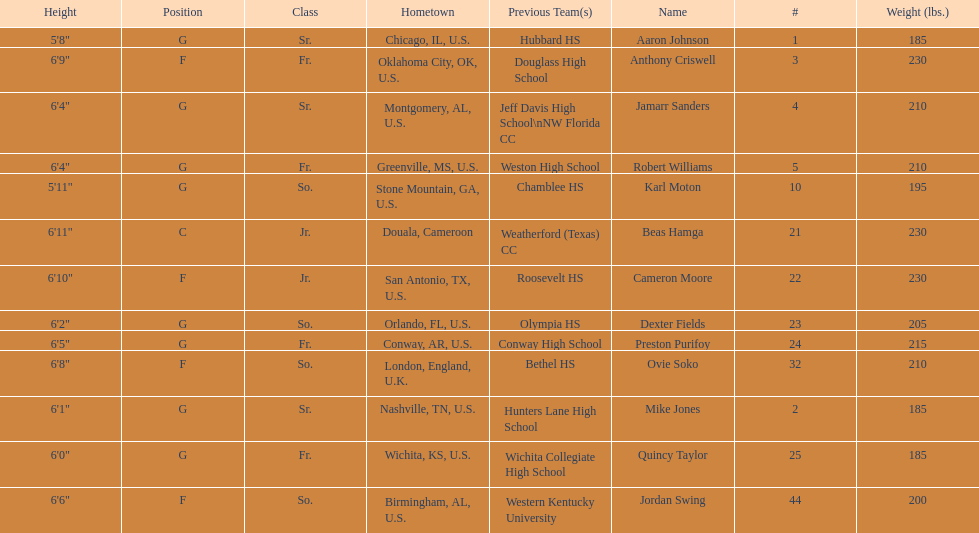What is the number of seniors on the team? 3. 